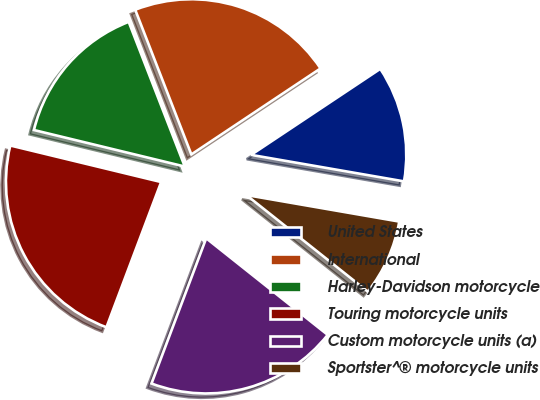<chart> <loc_0><loc_0><loc_500><loc_500><pie_chart><fcel>United States<fcel>International<fcel>Harley-Davidson motorcycle<fcel>Touring motorcycle units<fcel>Custom motorcycle units (a)<fcel>Sportster^® motorcycle units<nl><fcel>12.08%<fcel>21.54%<fcel>15.33%<fcel>23.05%<fcel>20.04%<fcel>7.96%<nl></chart> 